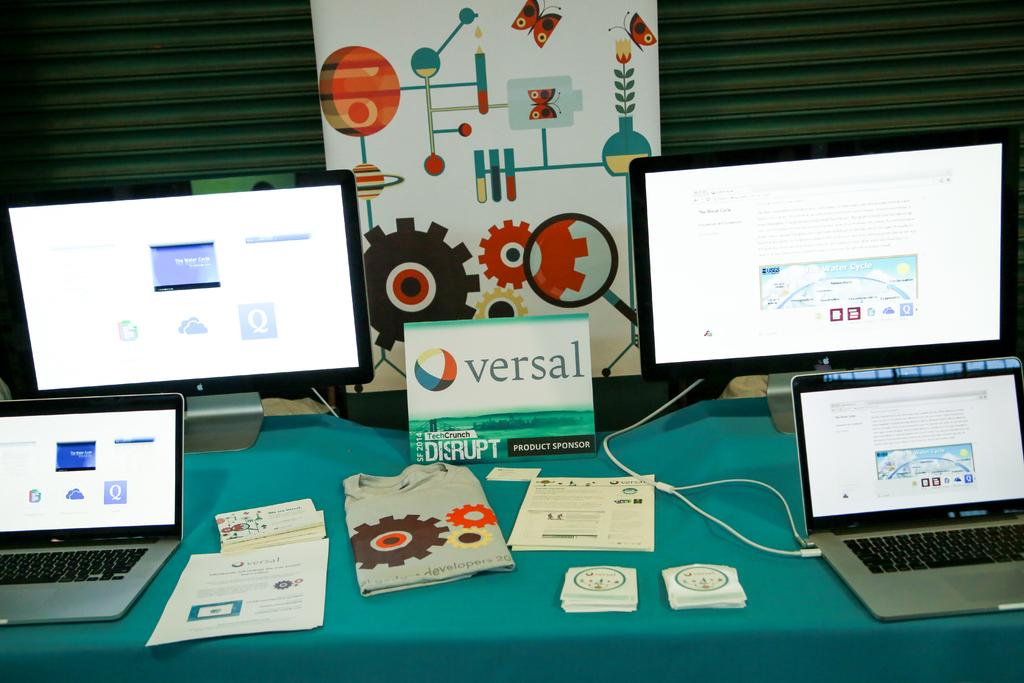<image>
Offer a succinct explanation of the picture presented. Laptops and monitors being displayed with a card showing the word "versal" on it. 